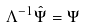<formula> <loc_0><loc_0><loc_500><loc_500>\Lambda ^ { - 1 } \hat { \Psi } = \Psi</formula> 